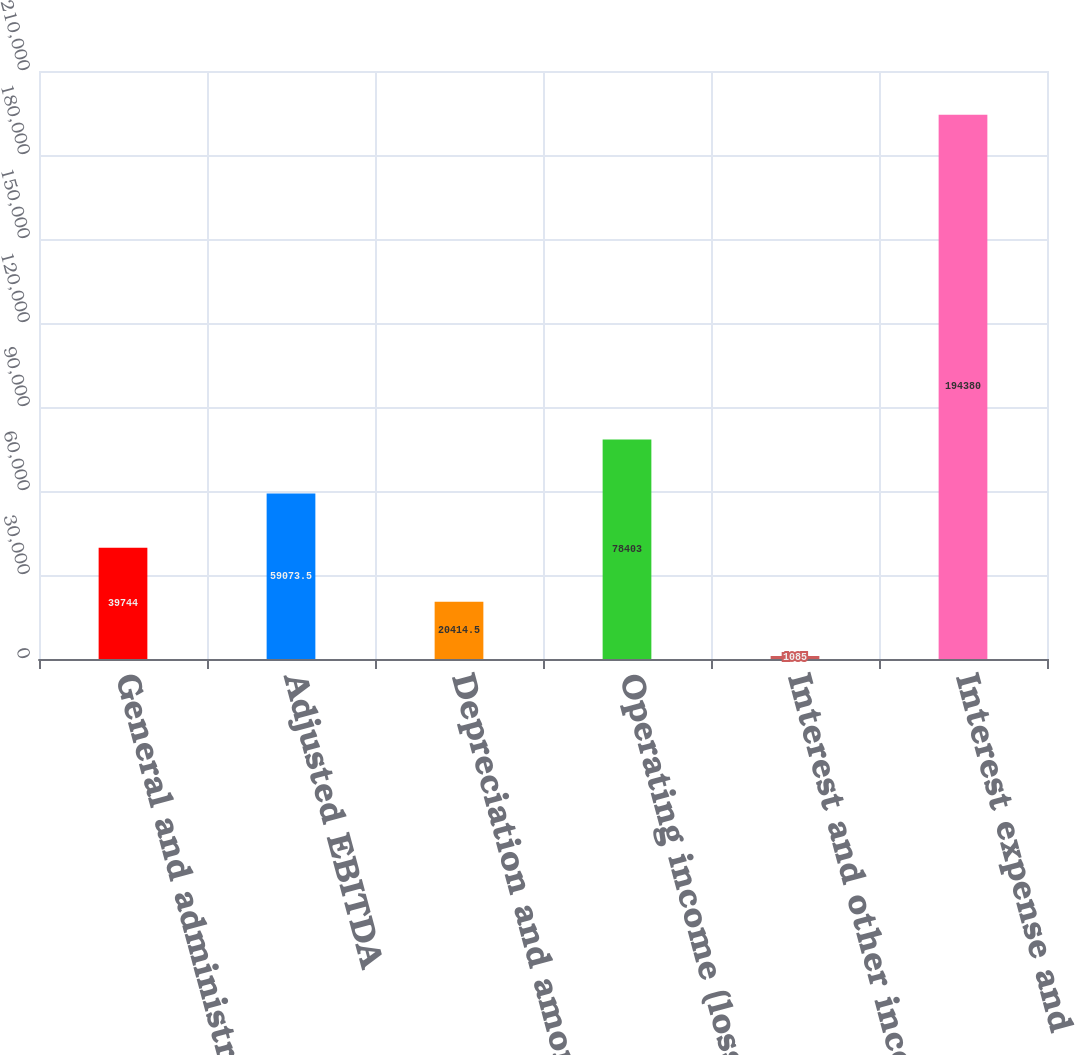<chart> <loc_0><loc_0><loc_500><loc_500><bar_chart><fcel>General and administrative<fcel>Adjusted EBITDA<fcel>Depreciation and amortization<fcel>Operating income (loss)<fcel>Interest and other income<fcel>Interest expense and<nl><fcel>39744<fcel>59073.5<fcel>20414.5<fcel>78403<fcel>1085<fcel>194380<nl></chart> 